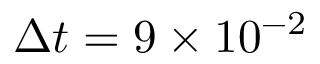<formula> <loc_0><loc_0><loc_500><loc_500>\Delta t = 9 \times 1 0 ^ { - 2 }</formula> 